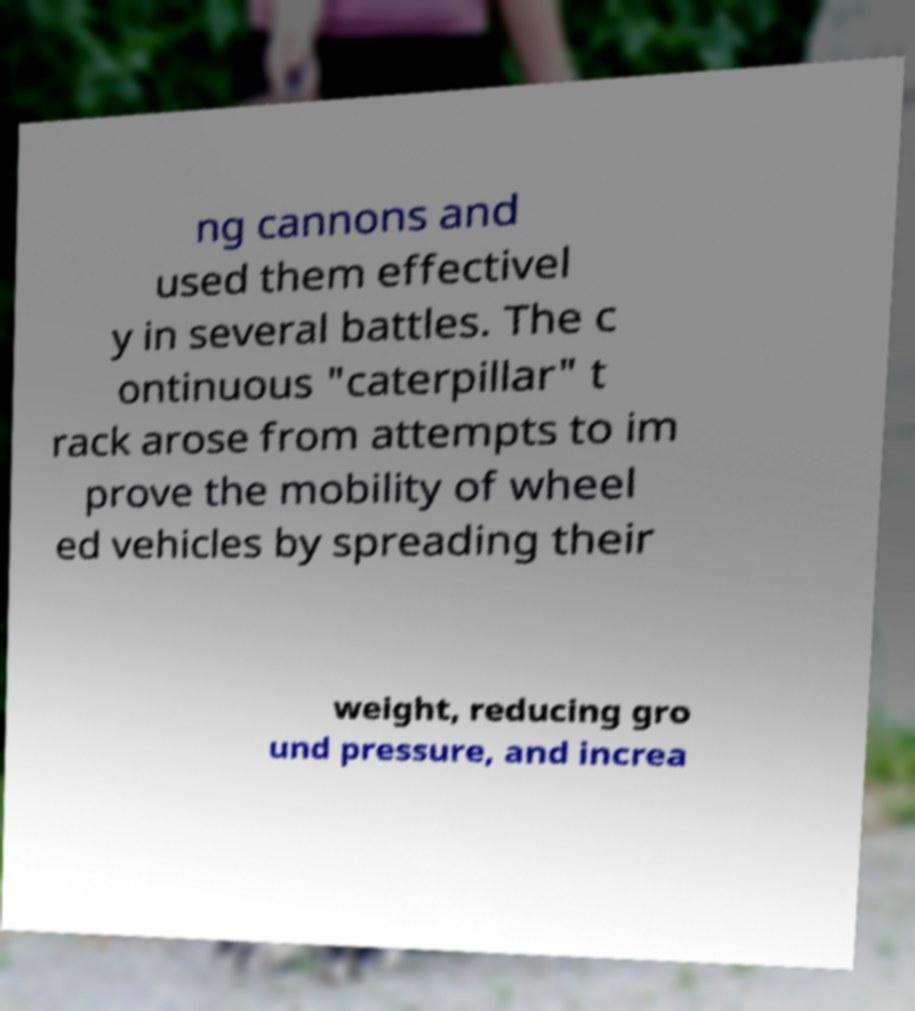Please identify and transcribe the text found in this image. ng cannons and used them effectivel y in several battles. The c ontinuous "caterpillar" t rack arose from attempts to im prove the mobility of wheel ed vehicles by spreading their weight, reducing gro und pressure, and increa 